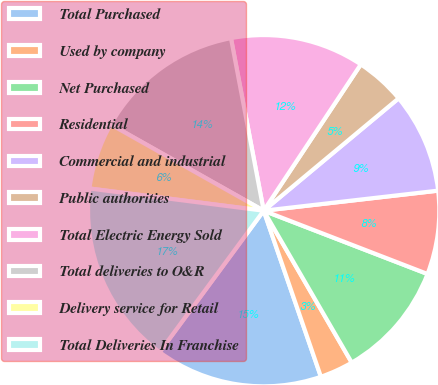<chart> <loc_0><loc_0><loc_500><loc_500><pie_chart><fcel>Total Purchased<fcel>Used by company<fcel>Net Purchased<fcel>Residential<fcel>Commercial and industrial<fcel>Public authorities<fcel>Total Electric Energy Sold<fcel>Total deliveries to O&R<fcel>Delivery service for Retail<fcel>Total Deliveries In Franchise<nl><fcel>15.38%<fcel>3.08%<fcel>10.77%<fcel>7.69%<fcel>9.23%<fcel>4.62%<fcel>12.31%<fcel>13.85%<fcel>6.15%<fcel>16.92%<nl></chart> 